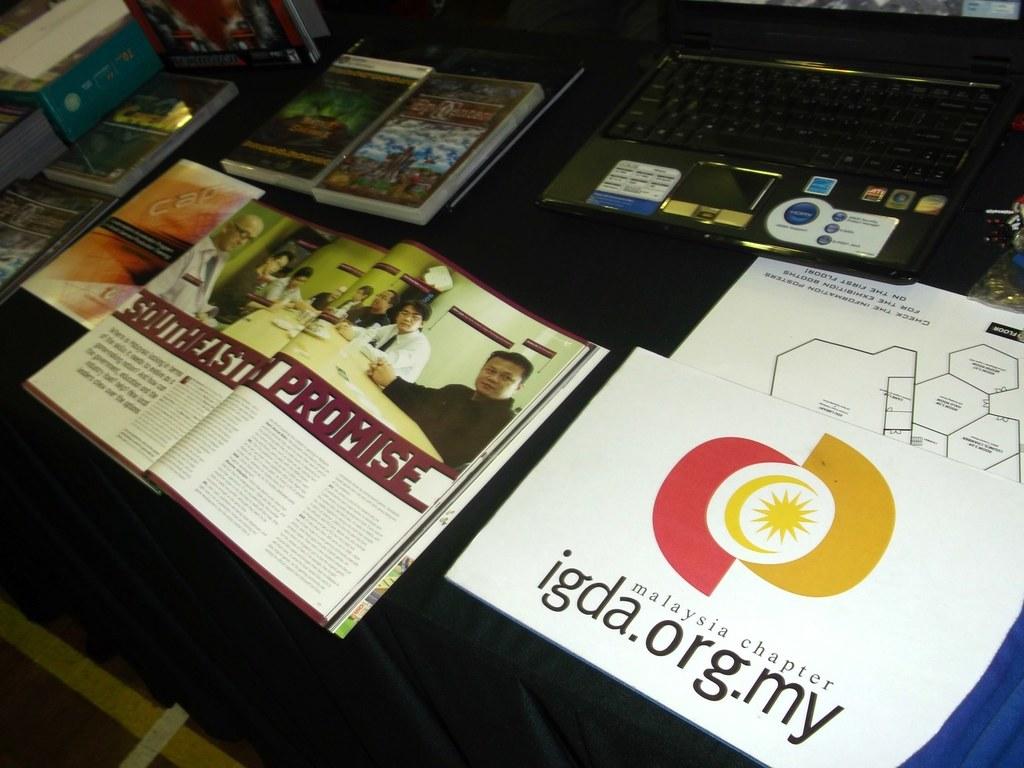What is the book promising?
Provide a succinct answer. Unanswerable. What is the website printed on the right?
Give a very brief answer. Igda.org.my. 